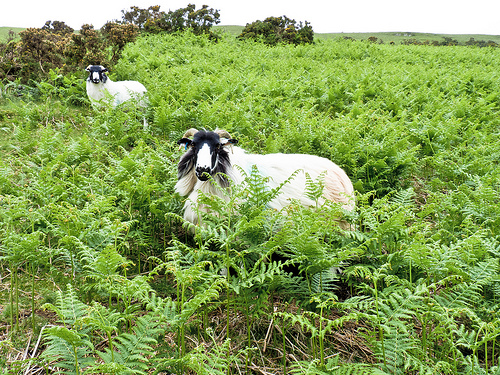What types of plants are surrounding the goats in the image? The goats are nestled among ferns and possibly some low shrubs, which are common in temperate climates and indicate a moist, fertile environment. 